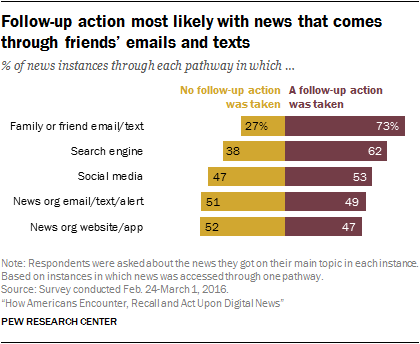Highlight a few significant elements in this photo. The percentage of patients who did not have follow-up after surgery was [47], while the percentage of patients who had follow-up after surgery was [53]. 